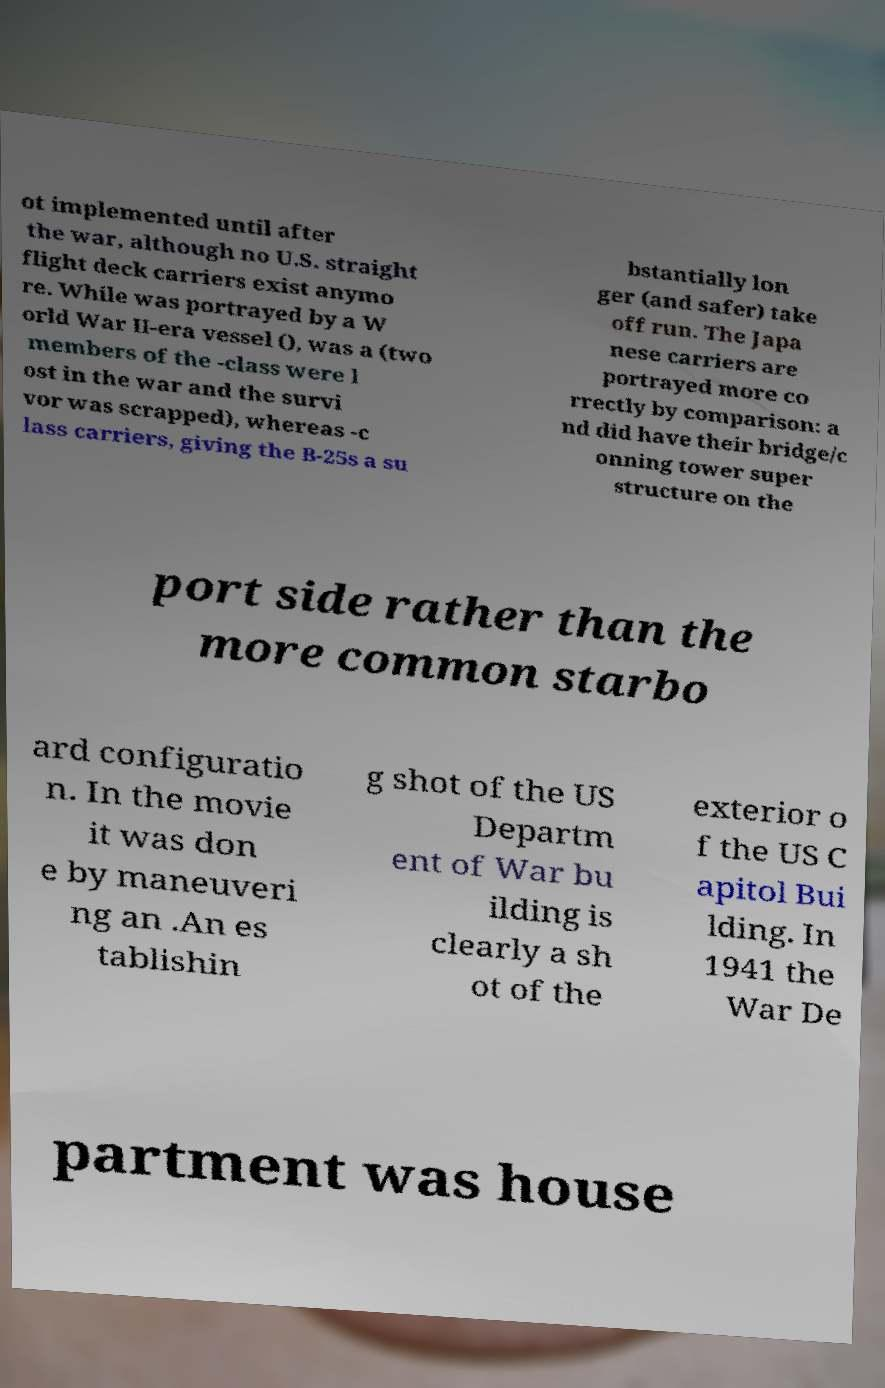Could you extract and type out the text from this image? ot implemented until after the war, although no U.S. straight flight deck carriers exist anymo re. While was portrayed by a W orld War II-era vessel (), was a (two members of the -class were l ost in the war and the survi vor was scrapped), whereas -c lass carriers, giving the B-25s a su bstantially lon ger (and safer) take off run. The Japa nese carriers are portrayed more co rrectly by comparison: a nd did have their bridge/c onning tower super structure on the port side rather than the more common starbo ard configuratio n. In the movie it was don e by maneuveri ng an .An es tablishin g shot of the US Departm ent of War bu ilding is clearly a sh ot of the exterior o f the US C apitol Bui lding. In 1941 the War De partment was house 